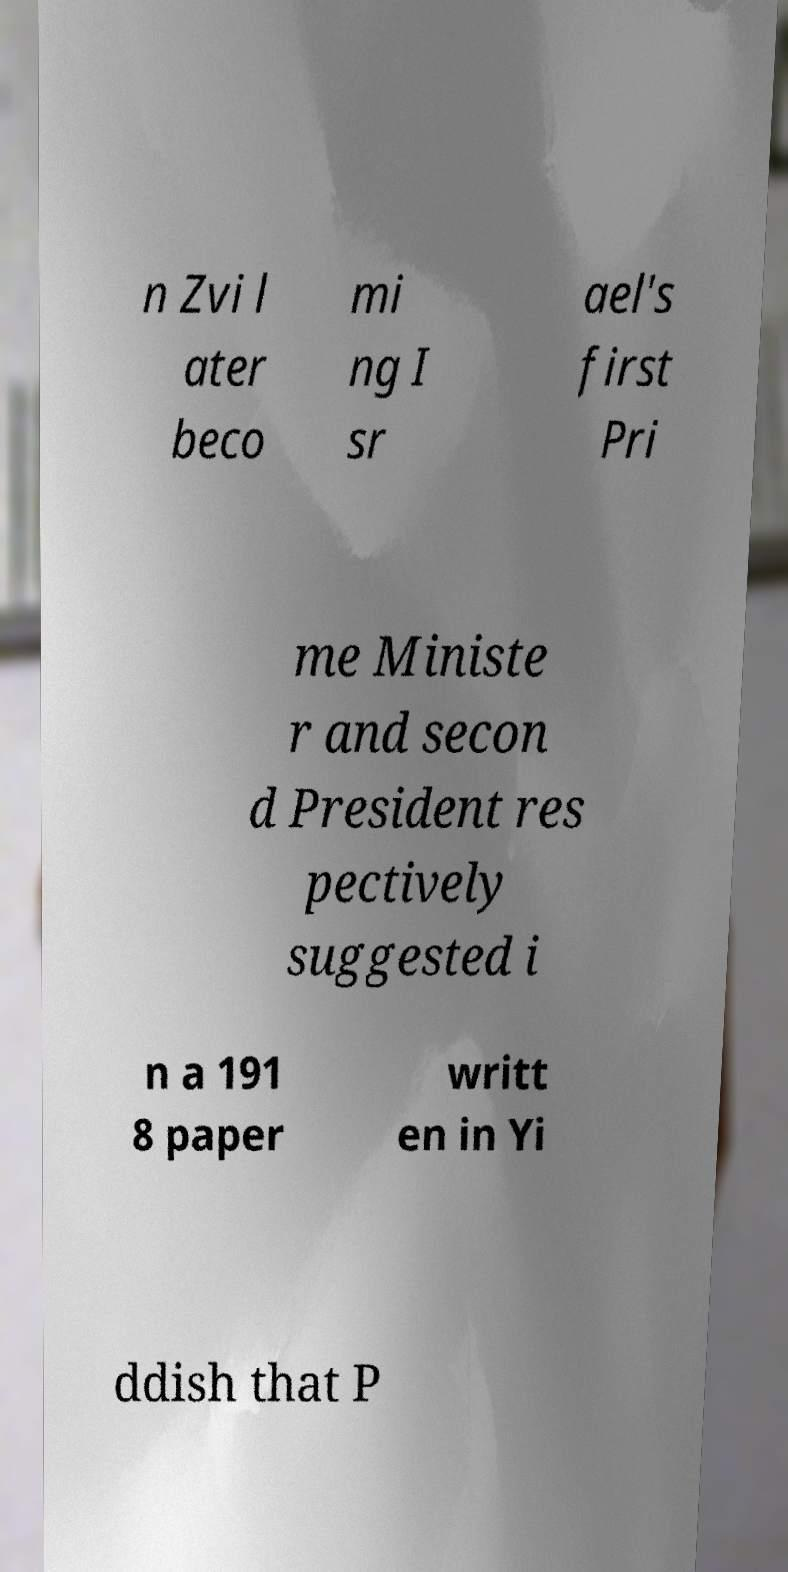Can you read and provide the text displayed in the image?This photo seems to have some interesting text. Can you extract and type it out for me? n Zvi l ater beco mi ng I sr ael's first Pri me Ministe r and secon d President res pectively suggested i n a 191 8 paper writt en in Yi ddish that P 